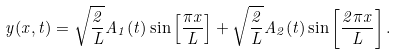Convert formula to latex. <formula><loc_0><loc_0><loc_500><loc_500>y ( x , t ) = \sqrt { \frac { 2 } { L } } A _ { 1 } ( t ) \sin \left [ \frac { \pi x } { L } \right ] + \sqrt { \frac { 2 } { L } } A _ { 2 } ( t ) \sin \left [ \frac { 2 \pi x } { L } \right ] .</formula> 